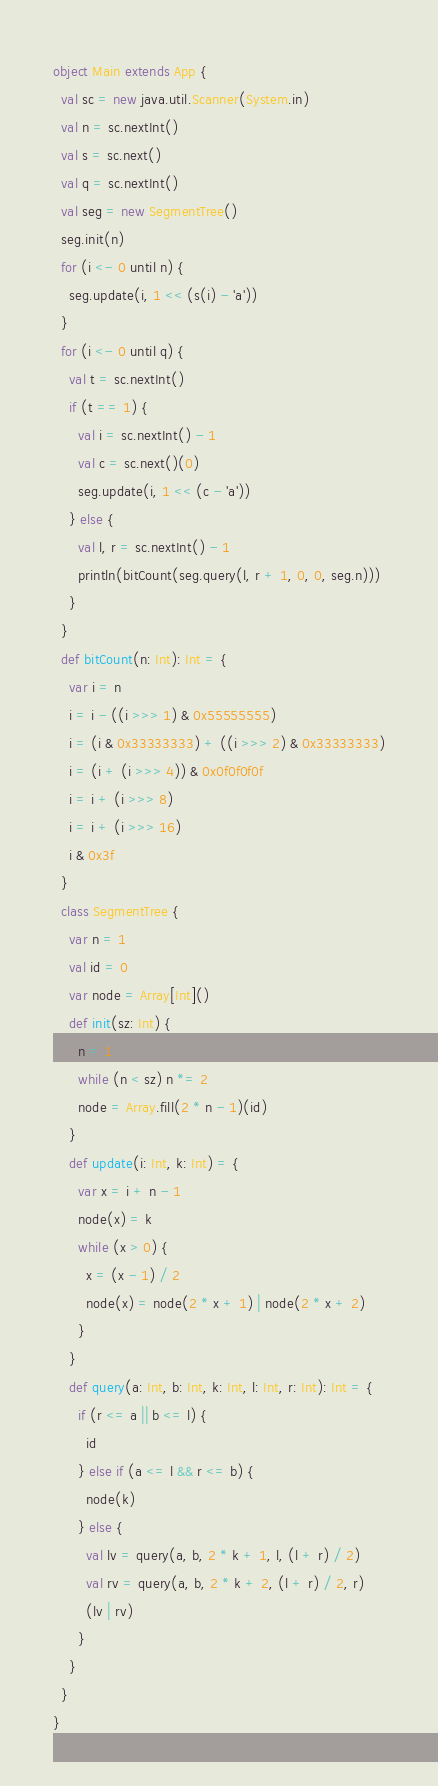Convert code to text. <code><loc_0><loc_0><loc_500><loc_500><_Scala_>object Main extends App {
  val sc = new java.util.Scanner(System.in)
  val n = sc.nextInt()
  val s = sc.next()
  val q = sc.nextInt()
  val seg = new SegmentTree()
  seg.init(n)
  for (i <- 0 until n) {
    seg.update(i, 1 << (s(i) - 'a'))
  }
  for (i <- 0 until q) {
    val t = sc.nextInt()
    if (t == 1) {
      val i = sc.nextInt() - 1
      val c = sc.next()(0)
      seg.update(i, 1 << (c - 'a'))
    } else {
      val l, r = sc.nextInt() - 1
      println(bitCount(seg.query(l, r + 1, 0, 0, seg.n)))
    }
  }
  def bitCount(n: Int): Int = {
    var i = n
    i = i - ((i >>> 1) & 0x55555555)
    i = (i & 0x33333333) + ((i >>> 2) & 0x33333333)
    i = (i + (i >>> 4)) & 0x0f0f0f0f
    i = i + (i >>> 8)
    i = i + (i >>> 16)
    i & 0x3f
  }
  class SegmentTree {
    var n = 1
    val id = 0
    var node = Array[Int]()
    def init(sz: Int) {
      n = 1
      while (n < sz) n *= 2
      node = Array.fill(2 * n - 1)(id)
    }
    def update(i: Int, k: Int) = {
      var x = i + n - 1
      node(x) = k
      while (x > 0) {
        x = (x - 1) / 2
        node(x) = node(2 * x + 1) | node(2 * x + 2)
      }
    }
    def query(a: Int, b: Int, k: Int, l: Int, r: Int): Int = {
      if (r <= a || b <= l) {
        id
      } else if (a <= l && r <= b) {
        node(k)
      } else {
        val lv = query(a, b, 2 * k + 1, l, (l + r) / 2)
        val rv = query(a, b, 2 * k + 2, (l + r) / 2, r)
        (lv | rv)
      }
    }
  }
}
</code> 